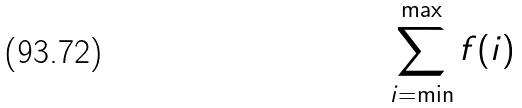Convert formula to latex. <formula><loc_0><loc_0><loc_500><loc_500>\sum _ { i = \min } ^ { \max } f ( i )</formula> 